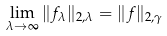<formula> <loc_0><loc_0><loc_500><loc_500>\lim _ { \lambda \to \infty } \| f _ { \lambda } \| _ { 2 , \lambda } = \| f \| _ { 2 , \gamma }</formula> 